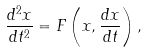Convert formula to latex. <formula><loc_0><loc_0><loc_500><loc_500>\frac { d ^ { 2 } x } { d t ^ { 2 } } = F \left ( x , \frac { d x } { d t } \right ) ,</formula> 